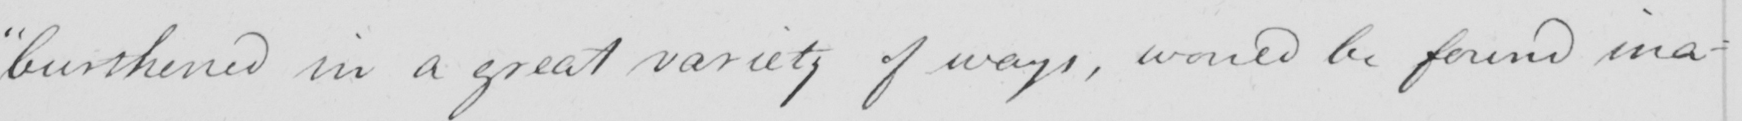Can you read and transcribe this handwriting? " burthened in a great variety of ways , would be found ina- 